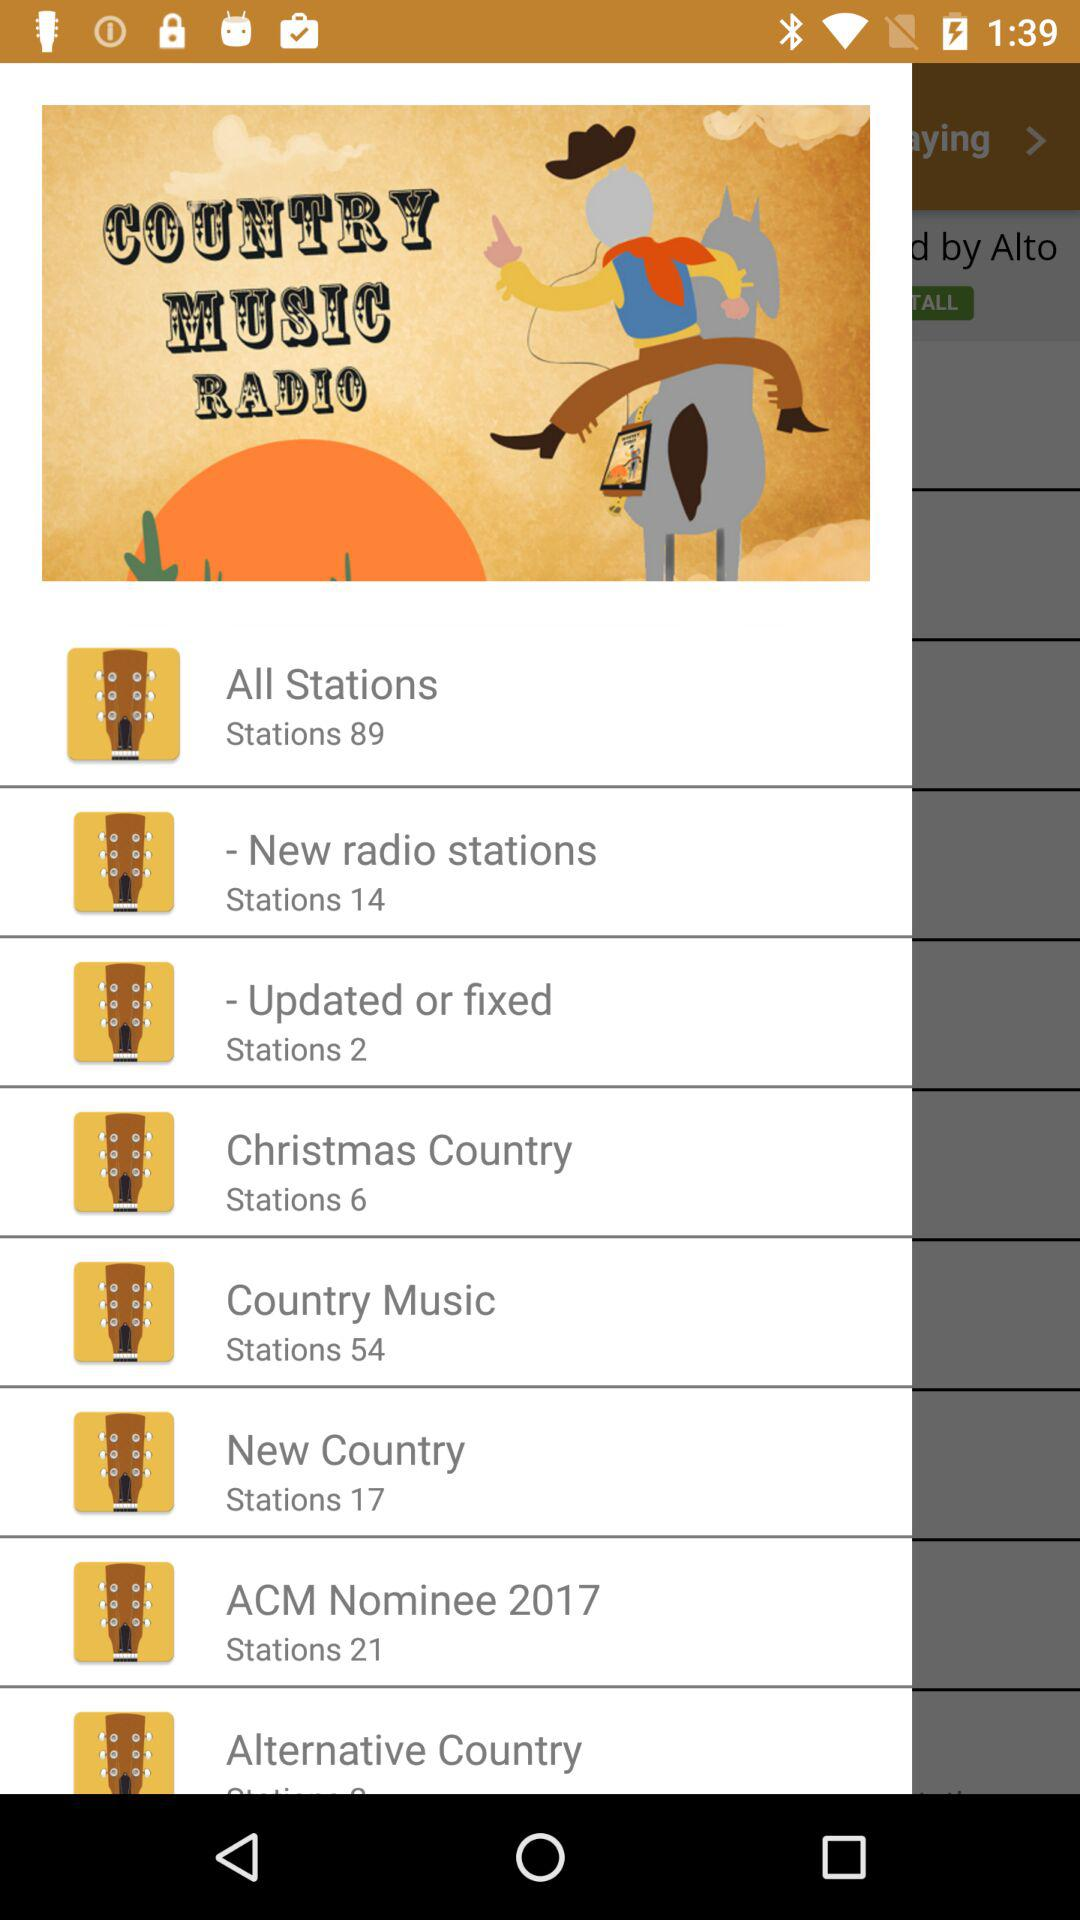How many stations are in "New Country"? There are 17 stations in "New Country". 